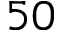<formula> <loc_0><loc_0><loc_500><loc_500>5 0</formula> 